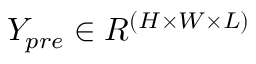<formula> <loc_0><loc_0><loc_500><loc_500>Y _ { p r e } \in R ^ { ( H \times W \times L ) }</formula> 